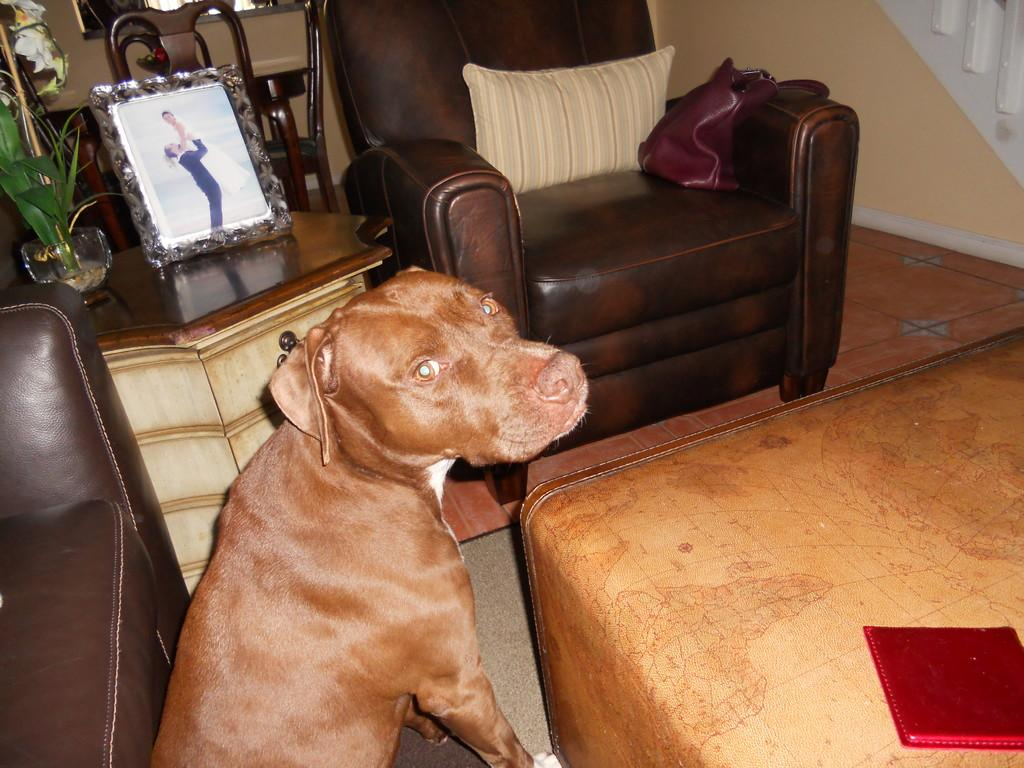What type of animal is present in the image? There is a dog in the image. Where is the dog positioned in relation to the furniture? The dog is standing in front of a brown sofa. What can be seen in the background of the image? There is a photo frame in the frame in the background of the image. Does the dog appear to be seeking approval from its aunt in the image? There is no indication of an aunt or approval-seeking behavior in the image; it simply shows a dog standing in front of a brown sofa. 